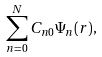<formula> <loc_0><loc_0><loc_500><loc_500>\sum _ { n = 0 } ^ { N } C _ { n 0 } \Psi _ { n } ( { r } ) ,</formula> 